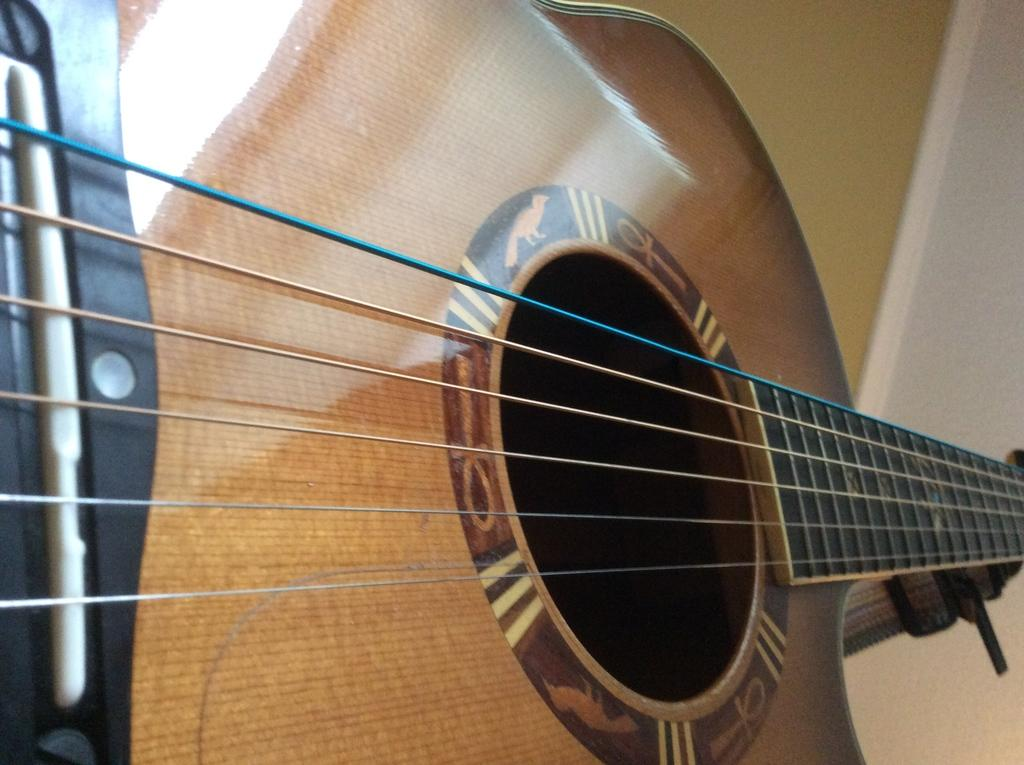What musical instrument is present in the image? There is a guitar in the image. What type of organization is associated with the guitar in the image? There is no organization mentioned or depicted in the image; it only features a guitar. 